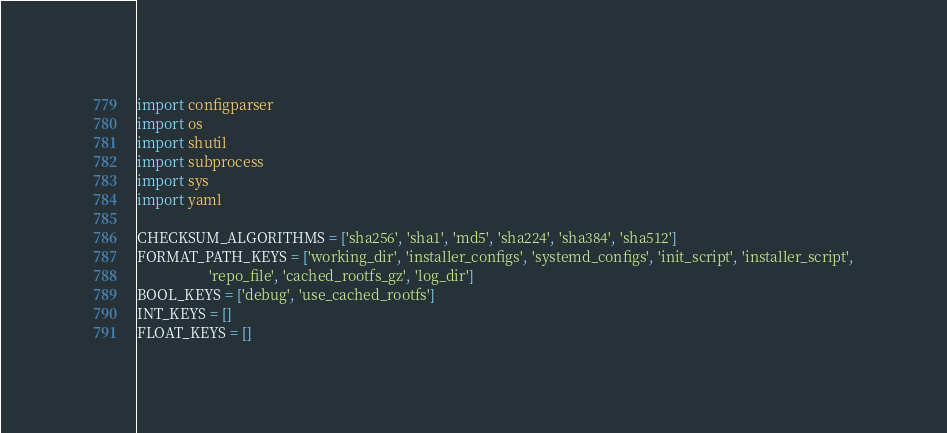Convert code to text. <code><loc_0><loc_0><loc_500><loc_500><_Python_>import configparser
import os
import shutil
import subprocess
import sys
import yaml

CHECKSUM_ALGORITHMS = ['sha256', 'sha1', 'md5', 'sha224', 'sha384', 'sha512']
FORMAT_PATH_KEYS = ['working_dir', 'installer_configs', 'systemd_configs', 'init_script', 'installer_script',
                    'repo_file', 'cached_rootfs_gz', 'log_dir']
BOOL_KEYS = ['debug', 'use_cached_rootfs']
INT_KEYS = []
FLOAT_KEYS = []

</code> 